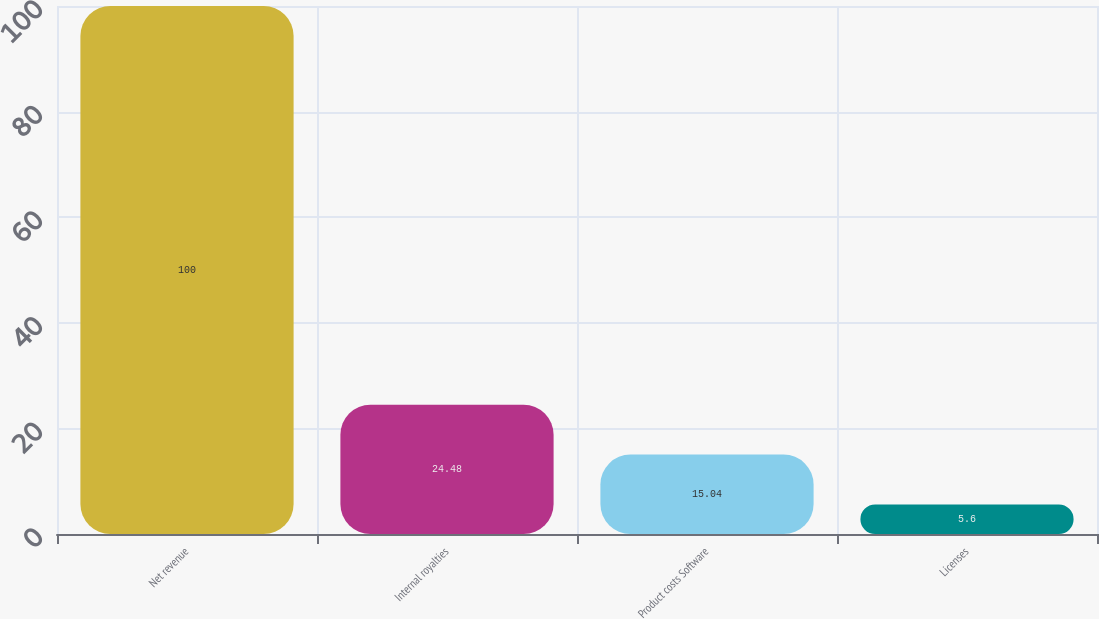Convert chart to OTSL. <chart><loc_0><loc_0><loc_500><loc_500><bar_chart><fcel>Net revenue<fcel>Internal royalties<fcel>Product costs Software<fcel>Licenses<nl><fcel>100<fcel>24.48<fcel>15.04<fcel>5.6<nl></chart> 